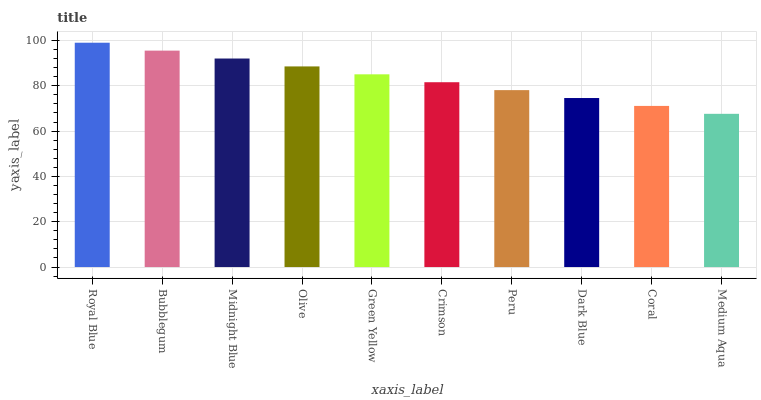Is Bubblegum the minimum?
Answer yes or no. No. Is Bubblegum the maximum?
Answer yes or no. No. Is Royal Blue greater than Bubblegum?
Answer yes or no. Yes. Is Bubblegum less than Royal Blue?
Answer yes or no. Yes. Is Bubblegum greater than Royal Blue?
Answer yes or no. No. Is Royal Blue less than Bubblegum?
Answer yes or no. No. Is Green Yellow the high median?
Answer yes or no. Yes. Is Crimson the low median?
Answer yes or no. Yes. Is Medium Aqua the high median?
Answer yes or no. No. Is Peru the low median?
Answer yes or no. No. 